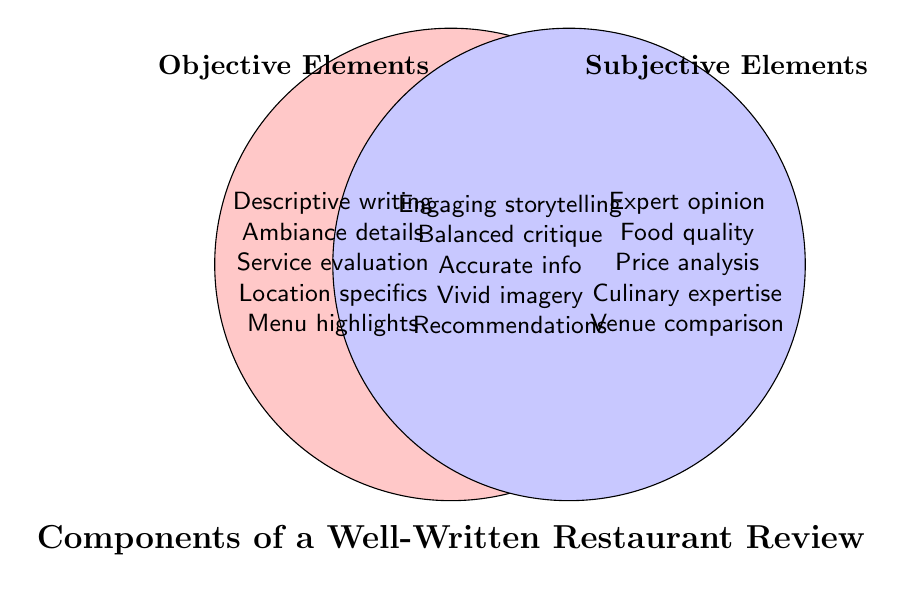What is the title of the Venn diagram? The bottom of the figure contains the title which reads "Components of a Well-Written Restaurant Review".
Answer: Components of a Well-Written Restaurant Review What are the two main categories represented in the circles? The two main categories are labeled near the top of each circle: "Objective Elements" on the left and "Subjective Elements" on the right.
Answer: Objective Elements, Subjective Elements Which elements are found exclusively in the "Objective Elements" category? The elements listed in the left circle include: Descriptive writing, Ambiance details, Service evaluation, Location specifics, and Menu highlights.
Answer: Descriptive writing, Ambiance details, Service evaluation, Location specifics, Menu highlights Which elements are common between the "Objective Elements" and "Subjective Elements" categories? The elements listed in the overlapping area of the two circles include: Engaging storytelling, Balanced critique, Accurate information, Vivid imagery, and Recommendations.
Answer: Engaging storytelling, Balanced critique, Accurate information, Vivid imagery, Recommendations How many elements are found in the "Subjective Elements" category that are not shared with the "Objective Elements" category? There are five elements listed in the right circle that are not shared: Expert opinion, Food quality, Price analysis, Culinary expertise, and Venue comparison.
Answer: Five (5) What category does "Menu highlights" belong to? "Menu highlights" is listed in the left circle, which means it belongs to the "Objective Elements" category.
Answer: Objective Elements Which elements from the "Subjective Elements" category relate to food? From the "Subjective Elements" category, the elements related to food include: Food quality and Culinary expertise.
Answer: Food quality, Culinary expertise Is "Balanced critique" an exclusive characteristic of either objective or subjective reviews? No, "Balanced critique" is found in the overlapping area, indicating it is a characteristic shared by both objective and subjective reviews.
Answer: No List three elements that require expertise to review. Elements that require expertise, found in the right circle or the overlapping section, are: Expert opinion, Culinary expertise, and Balanced critique.
Answer: Expert opinion, Culinary expertise, Balanced critique 